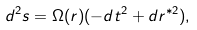<formula> <loc_0><loc_0><loc_500><loc_500>d ^ { 2 } s = \Omega ( r ) ( - d t ^ { 2 } + d r ^ { \ast 2 } ) ,</formula> 